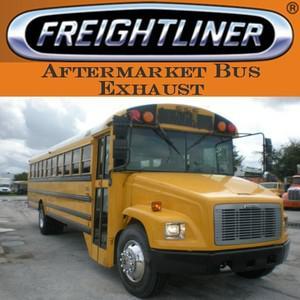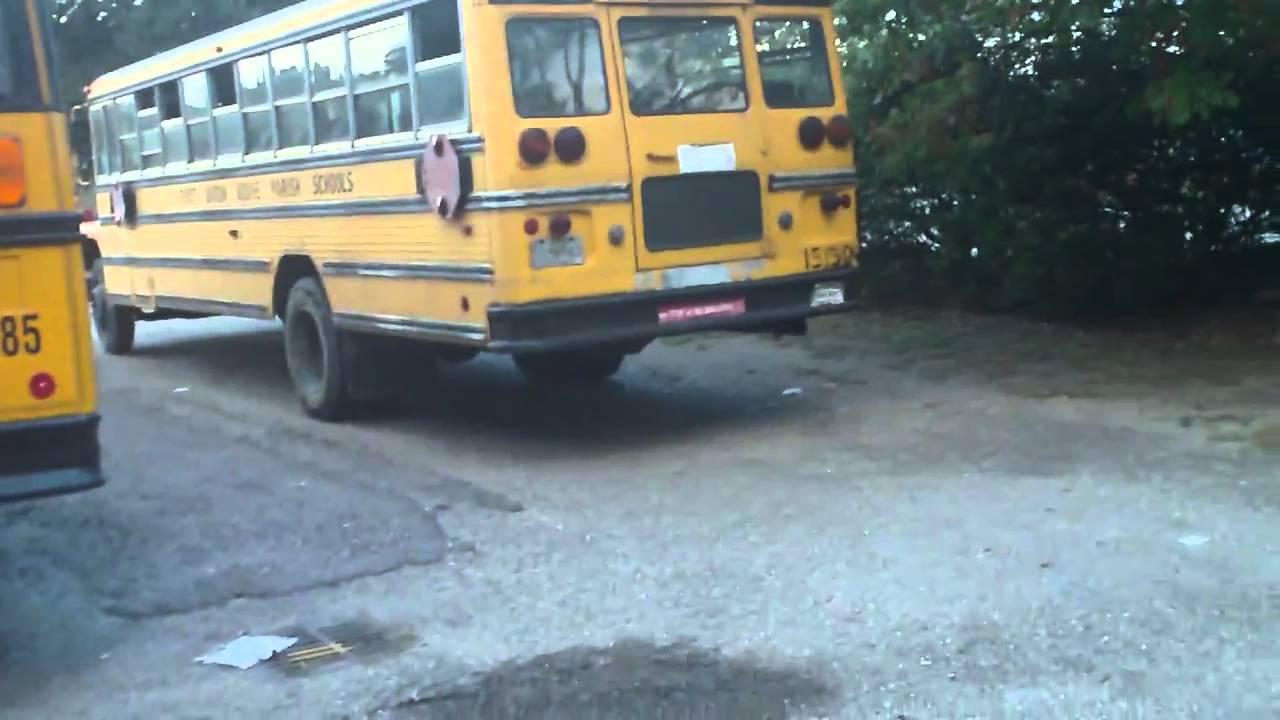The first image is the image on the left, the second image is the image on the right. Considering the images on both sides, is "The left and right image contains the same number of buses." valid? Answer yes or no. No. 